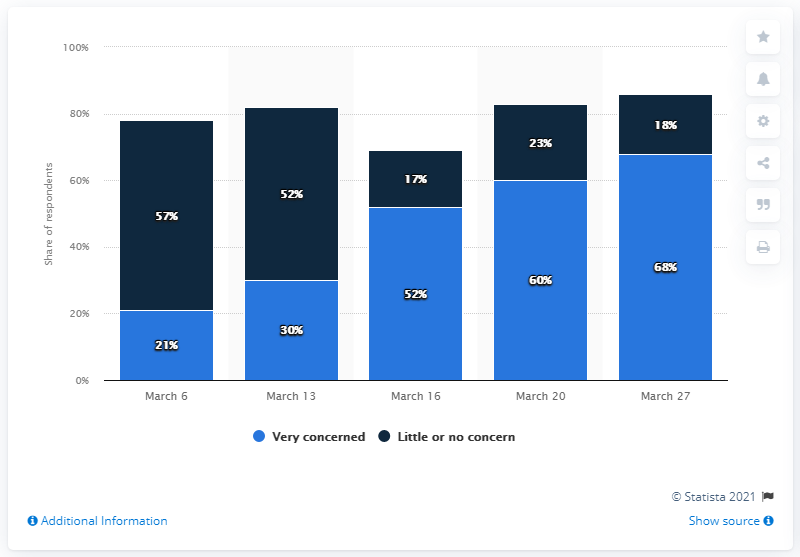Identify some key points in this picture. The people perceived little or no concern for fear below 50% for approximately 3 days. On March 16th, 52% of people were very concerned. 